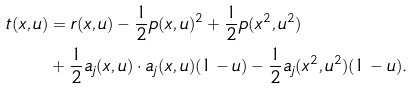Convert formula to latex. <formula><loc_0><loc_0><loc_500><loc_500>t ( x , u ) & = r ( x , u ) - \frac { 1 } { 2 } p ( x , u ) ^ { 2 } + \frac { 1 } { 2 } p ( x ^ { 2 } , u ^ { 2 } ) \\ & + \frac { 1 } { 2 } a _ { j } ( x , u ) \cdot a _ { j } ( x , u ) ( 1 - u ) - \frac { 1 } { 2 } a _ { j } ( x ^ { 2 } , u ^ { 2 } ) ( 1 - u ) .</formula> 